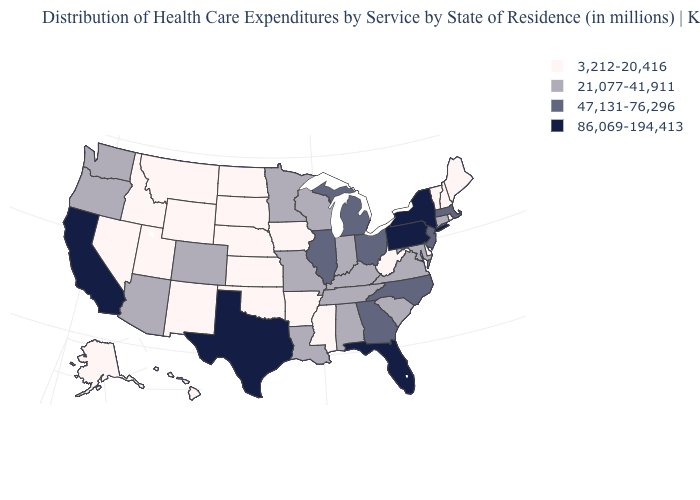Which states have the lowest value in the MidWest?
Be succinct. Iowa, Kansas, Nebraska, North Dakota, South Dakota. Does the first symbol in the legend represent the smallest category?
Write a very short answer. Yes. Name the states that have a value in the range 3,212-20,416?
Answer briefly. Alaska, Arkansas, Delaware, Hawaii, Idaho, Iowa, Kansas, Maine, Mississippi, Montana, Nebraska, Nevada, New Hampshire, New Mexico, North Dakota, Oklahoma, Rhode Island, South Dakota, Utah, Vermont, West Virginia, Wyoming. What is the lowest value in the USA?
Write a very short answer. 3,212-20,416. Which states hav the highest value in the Northeast?
Give a very brief answer. New York, Pennsylvania. What is the value of New Mexico?
Short answer required. 3,212-20,416. Among the states that border Delaware , which have the lowest value?
Keep it brief. Maryland. What is the lowest value in the West?
Quick response, please. 3,212-20,416. Does the first symbol in the legend represent the smallest category?
Quick response, please. Yes. Does Kansas have the same value as New Mexico?
Short answer required. Yes. What is the value of Ohio?
Write a very short answer. 47,131-76,296. What is the highest value in the MidWest ?
Keep it brief. 47,131-76,296. Name the states that have a value in the range 21,077-41,911?
Quick response, please. Alabama, Arizona, Colorado, Connecticut, Indiana, Kentucky, Louisiana, Maryland, Minnesota, Missouri, Oregon, South Carolina, Tennessee, Virginia, Washington, Wisconsin. What is the highest value in the USA?
Short answer required. 86,069-194,413. Name the states that have a value in the range 86,069-194,413?
Quick response, please. California, Florida, New York, Pennsylvania, Texas. 